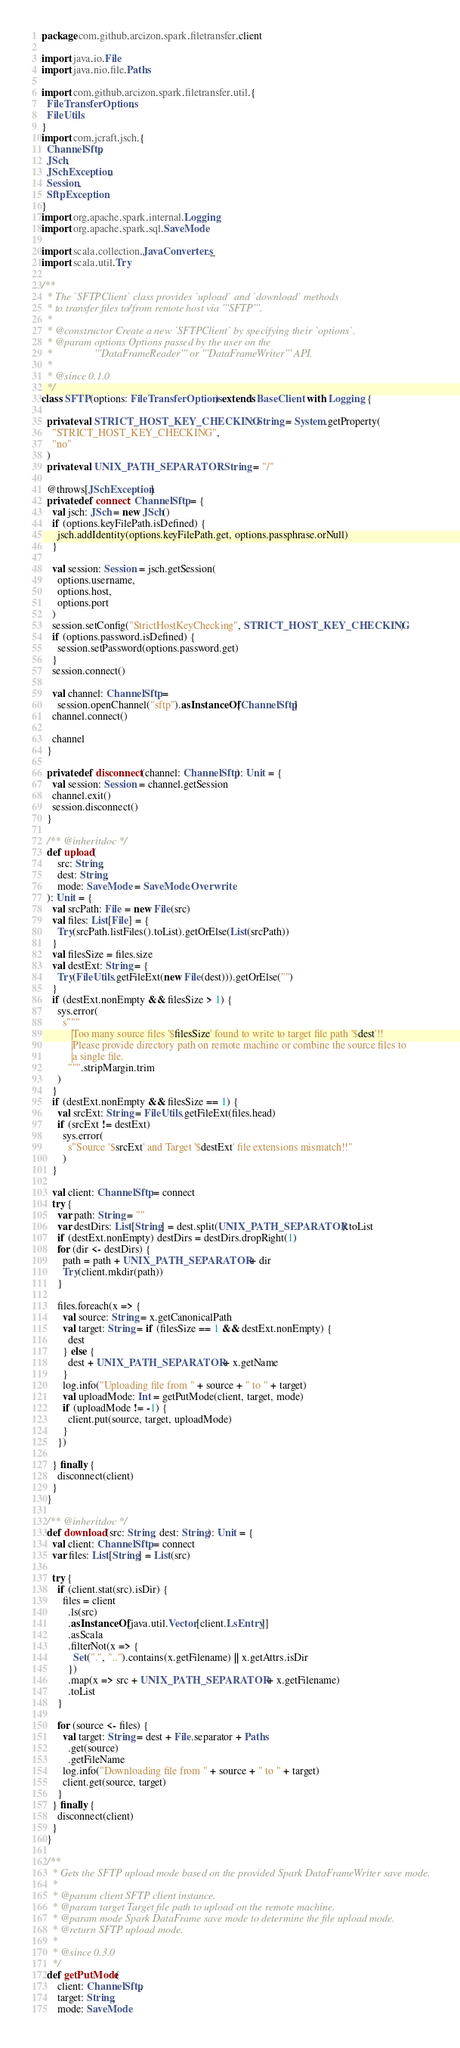Convert code to text. <code><loc_0><loc_0><loc_500><loc_500><_Scala_>package com.github.arcizon.spark.filetransfer.client

import java.io.File
import java.nio.file.Paths

import com.github.arcizon.spark.filetransfer.util.{
  FileTransferOptions,
  FileUtils
}
import com.jcraft.jsch.{
  ChannelSftp,
  JSch,
  JSchException,
  Session,
  SftpException
}
import org.apache.spark.internal.Logging
import org.apache.spark.sql.SaveMode

import scala.collection.JavaConverters._
import scala.util.Try

/**
  * The `SFTPClient` class provides `upload` and `download` methods
  * to transfer files to/from remote host via '''SFTP'''.
  *
  * @constructor Create a new `SFTPClient` by specifying their `options`.
  * @param options Options passed by the user on the
  *                '''DataFrameReader''' or '''DataFrameWriter''' API.
  *
  * @since 0.1.0
  */
class SFTP(options: FileTransferOptions) extends BaseClient with Logging {

  private val STRICT_HOST_KEY_CHECKING: String = System.getProperty(
    "STRICT_HOST_KEY_CHECKING",
    "no"
  )
  private val UNIX_PATH_SEPARATOR: String = "/"

  @throws[JSchException]
  private def connect: ChannelSftp = {
    val jsch: JSch = new JSch()
    if (options.keyFilePath.isDefined) {
      jsch.addIdentity(options.keyFilePath.get, options.passphrase.orNull)
    }

    val session: Session = jsch.getSession(
      options.username,
      options.host,
      options.port
    )
    session.setConfig("StrictHostKeyChecking", STRICT_HOST_KEY_CHECKING)
    if (options.password.isDefined) {
      session.setPassword(options.password.get)
    }
    session.connect()

    val channel: ChannelSftp =
      session.openChannel("sftp").asInstanceOf[ChannelSftp]
    channel.connect()

    channel
  }

  private def disconnect(channel: ChannelSftp): Unit = {
    val session: Session = channel.getSession
    channel.exit()
    session.disconnect()
  }

  /** @inheritdoc */
  def upload(
      src: String,
      dest: String,
      mode: SaveMode = SaveMode.Overwrite
  ): Unit = {
    val srcPath: File = new File(src)
    val files: List[File] = {
      Try(srcPath.listFiles().toList).getOrElse(List(srcPath))
    }
    val filesSize = files.size
    val destExt: String = {
      Try(FileUtils.getFileExt(new File(dest))).getOrElse("")
    }
    if (destExt.nonEmpty && filesSize > 1) {
      sys.error(
        s"""
           |Too many source files '$filesSize' found to write to target file path '$dest'!!
           |Please provide directory path on remote machine or combine the source files to
           |a single file.
          """.stripMargin.trim
      )
    }
    if (destExt.nonEmpty && filesSize == 1) {
      val srcExt: String = FileUtils.getFileExt(files.head)
      if (srcExt != destExt)
        sys.error(
          s"Source '$srcExt' and Target '$destExt' file extensions mismatch!!"
        )
    }

    val client: ChannelSftp = connect
    try {
      var path: String = ""
      var destDirs: List[String] = dest.split(UNIX_PATH_SEPARATOR).toList
      if (destExt.nonEmpty) destDirs = destDirs.dropRight(1)
      for (dir <- destDirs) {
        path = path + UNIX_PATH_SEPARATOR + dir
        Try(client.mkdir(path))
      }

      files.foreach(x => {
        val source: String = x.getCanonicalPath
        val target: String = if (filesSize == 1 && destExt.nonEmpty) {
          dest
        } else {
          dest + UNIX_PATH_SEPARATOR + x.getName
        }
        log.info("Uploading file from " + source + " to " + target)
        val uploadMode: Int = getPutMode(client, target, mode)
        if (uploadMode != -1) {
          client.put(source, target, uploadMode)
        }
      })

    } finally {
      disconnect(client)
    }
  }

  /** @inheritdoc */
  def download(src: String, dest: String): Unit = {
    val client: ChannelSftp = connect
    var files: List[String] = List(src)

    try {
      if (client.stat(src).isDir) {
        files = client
          .ls(src)
          .asInstanceOf[java.util.Vector[client.LsEntry]]
          .asScala
          .filterNot(x => {
            Set(".", "..").contains(x.getFilename) || x.getAttrs.isDir
          })
          .map(x => src + UNIX_PATH_SEPARATOR + x.getFilename)
          .toList
      }

      for (source <- files) {
        val target: String = dest + File.separator + Paths
          .get(source)
          .getFileName
        log.info("Downloading file from " + source + " to " + target)
        client.get(source, target)
      }
    } finally {
      disconnect(client)
    }
  }

  /**
    * Gets the SFTP upload mode based on the provided Spark DataFrameWriter save mode.
    *
    * @param client SFTP client instance.
    * @param target Target file path to upload on the remote machine.
    * @param mode Spark DataFrame save mode to determine the file upload mode.
    * @return SFTP upload mode.
    *
    * @since 0.3.0
    */
  def getPutMode(
      client: ChannelSftp,
      target: String,
      mode: SaveMode</code> 